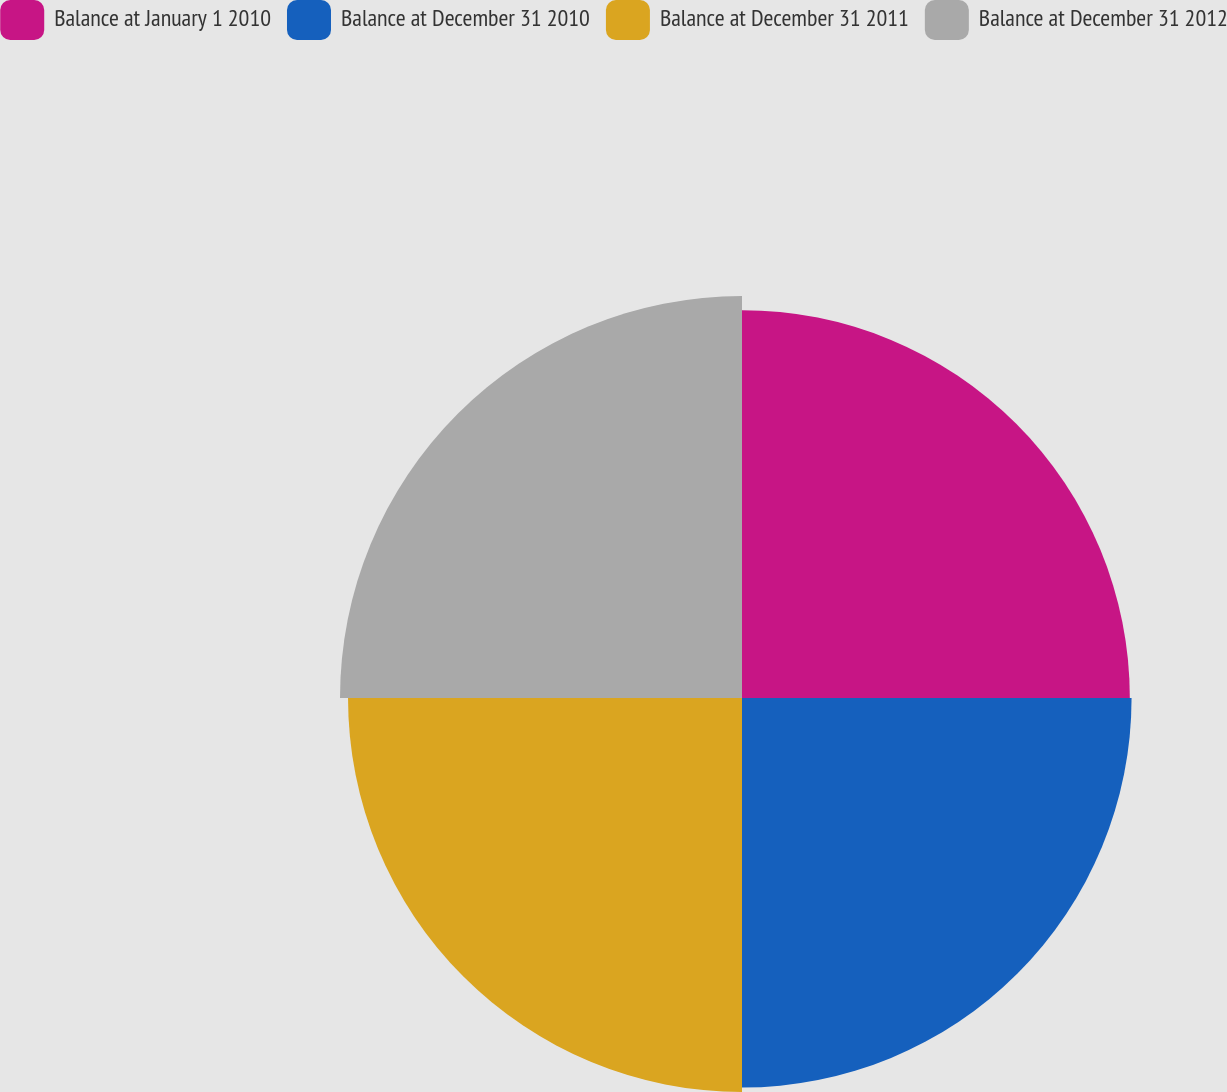Convert chart to OTSL. <chart><loc_0><loc_0><loc_500><loc_500><pie_chart><fcel>Balance at January 1 2010<fcel>Balance at December 31 2010<fcel>Balance at December 31 2011<fcel>Balance at December 31 2012<nl><fcel>24.65%<fcel>24.76%<fcel>25.04%<fcel>25.55%<nl></chart> 